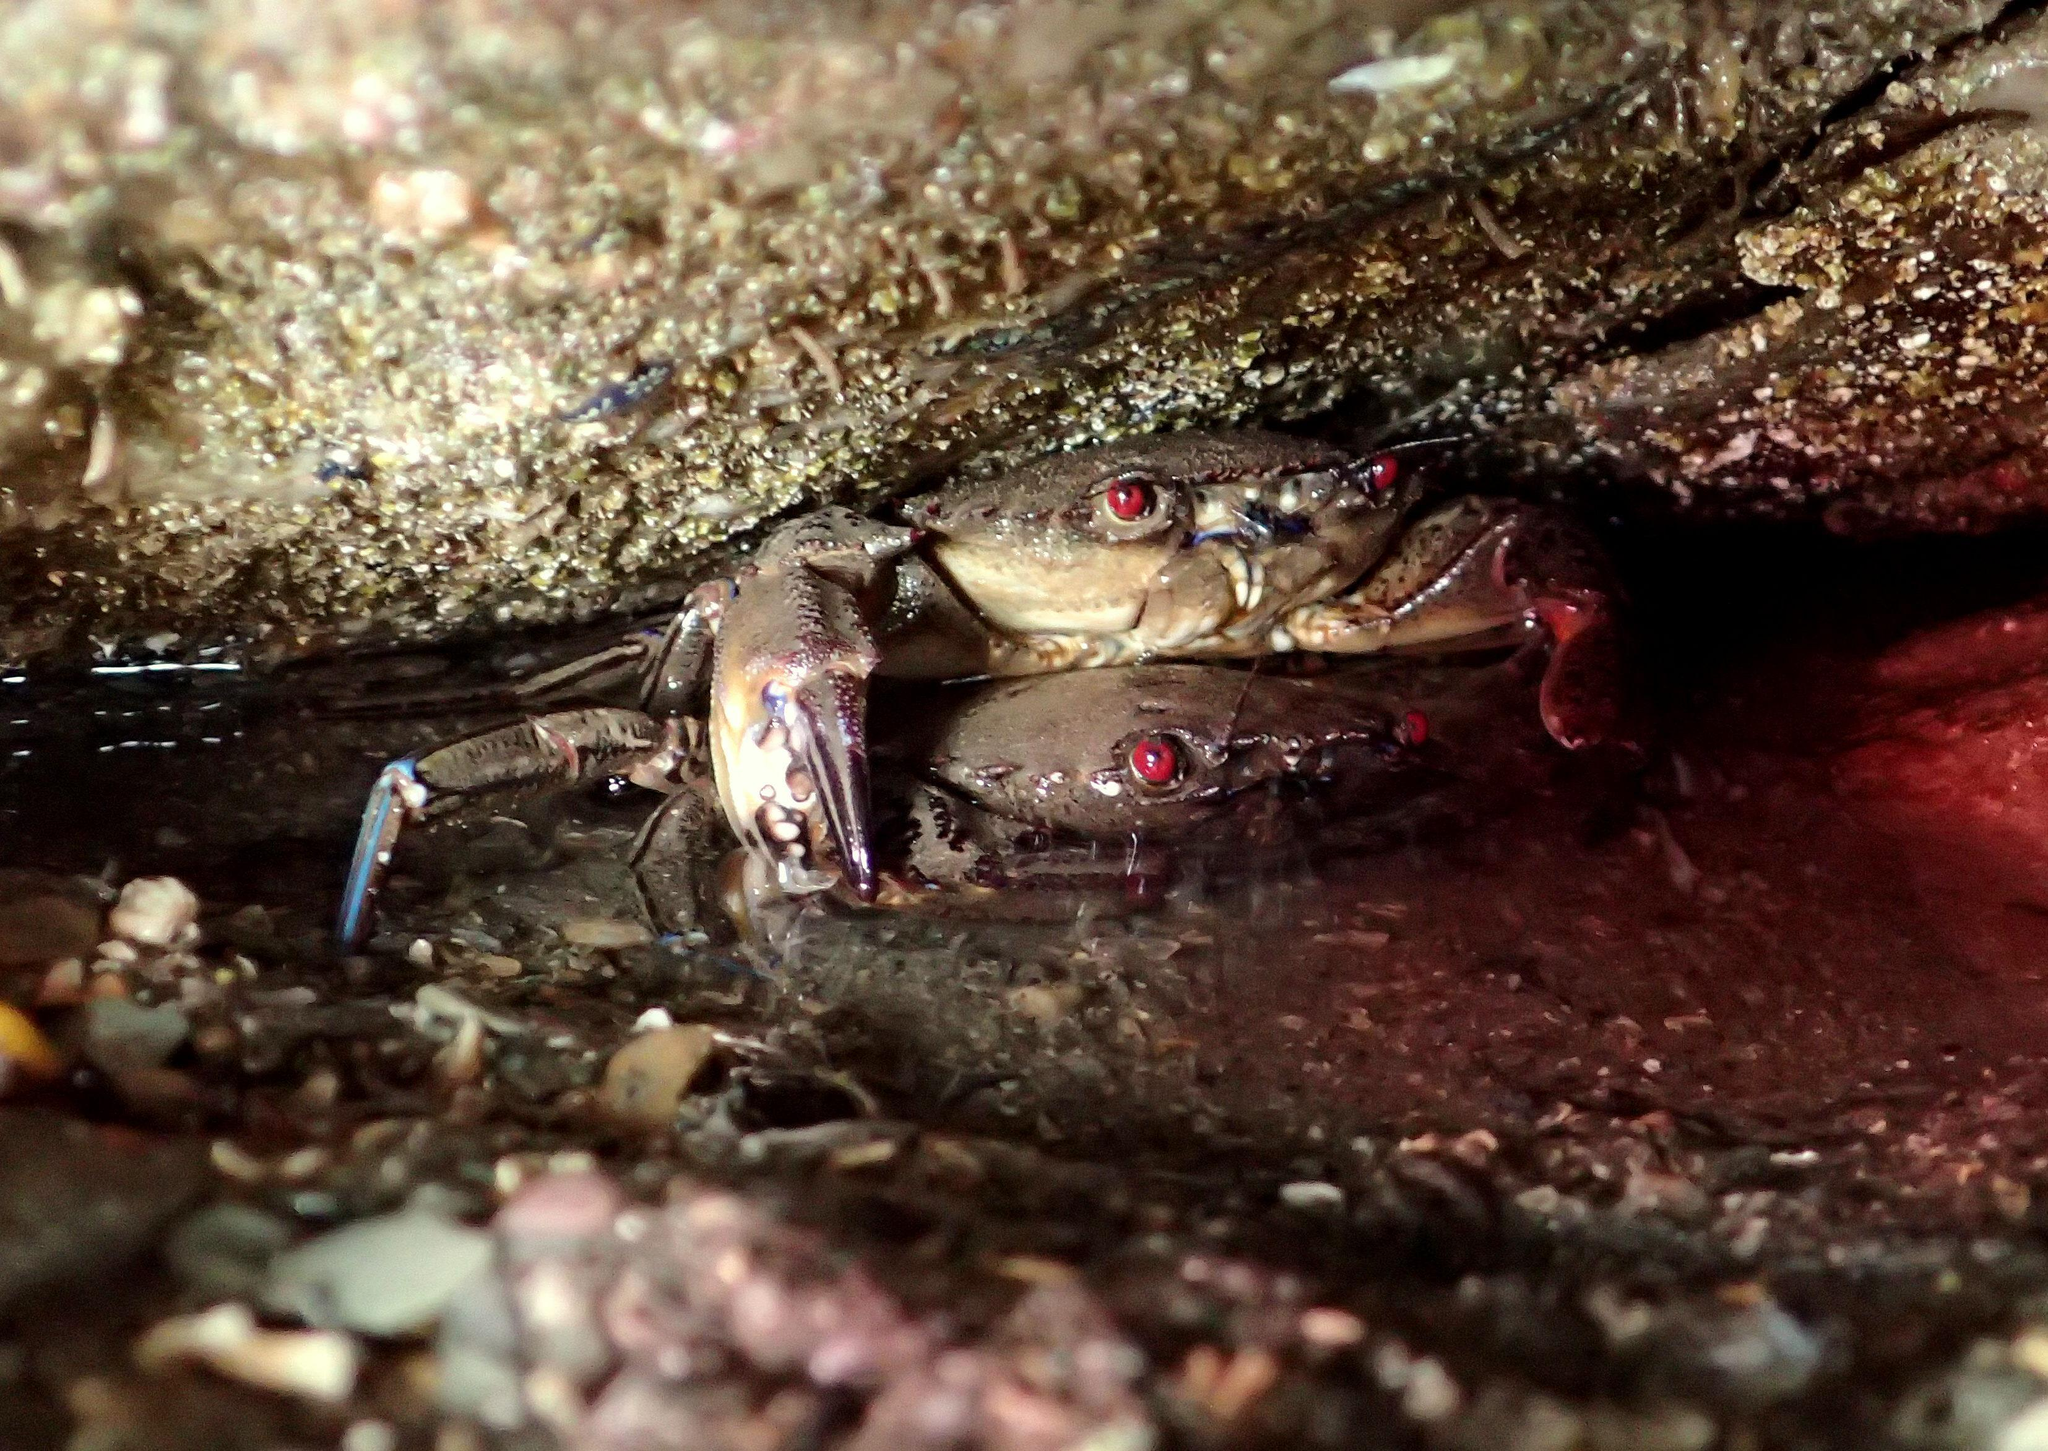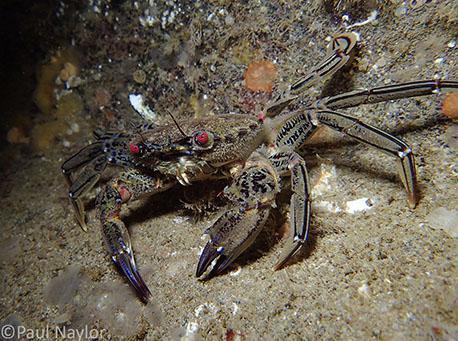The first image is the image on the left, the second image is the image on the right. Analyze the images presented: Is the assertion "Three pairs of eyes are visible." valid? Answer yes or no. Yes. 